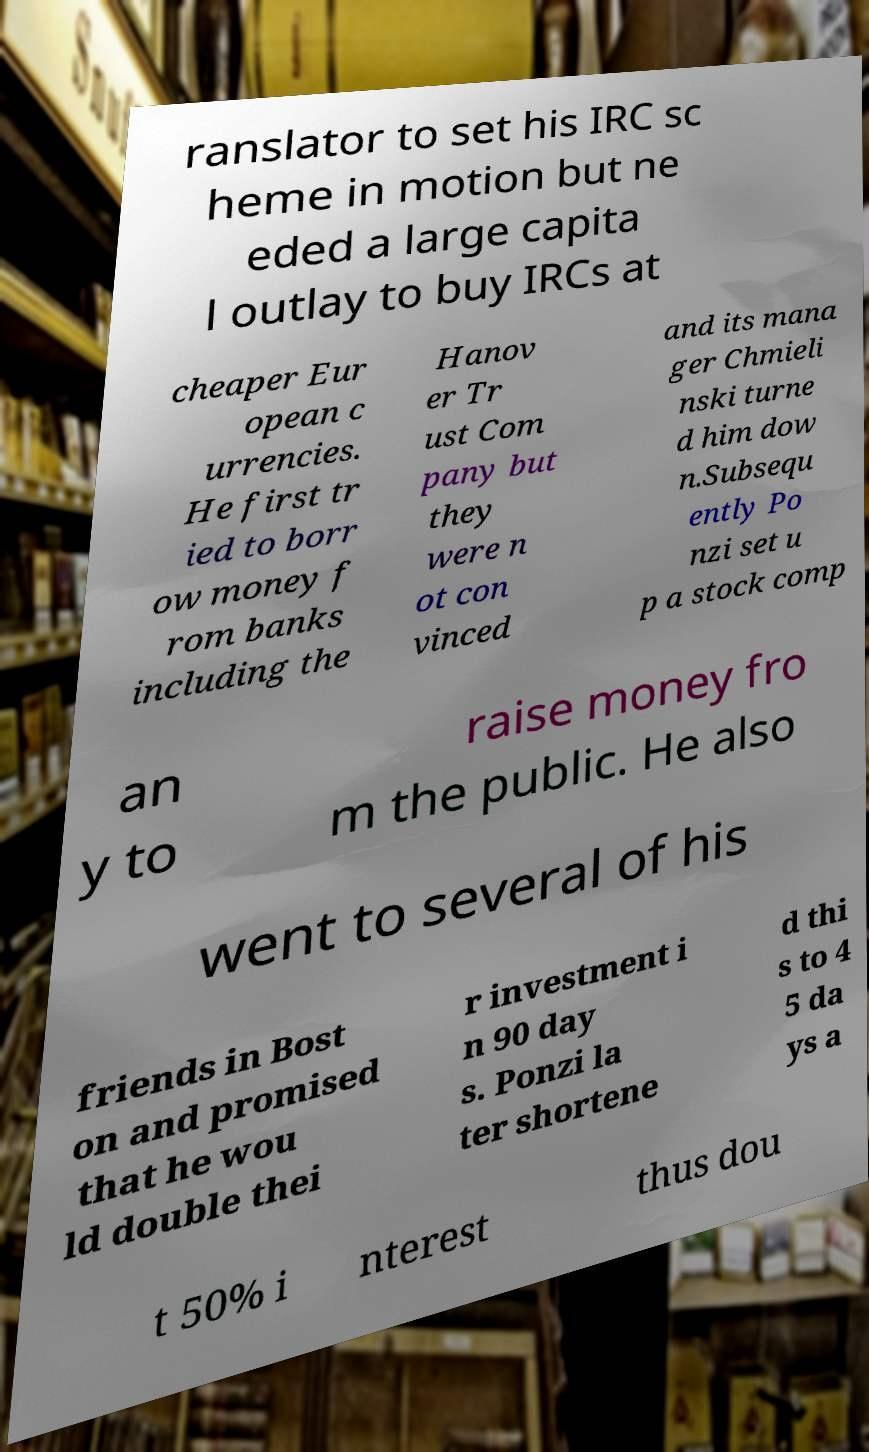Could you assist in decoding the text presented in this image and type it out clearly? ranslator to set his IRC sc heme in motion but ne eded a large capita l outlay to buy IRCs at cheaper Eur opean c urrencies. He first tr ied to borr ow money f rom banks including the Hanov er Tr ust Com pany but they were n ot con vinced and its mana ger Chmieli nski turne d him dow n.Subsequ ently Po nzi set u p a stock comp an y to raise money fro m the public. He also went to several of his friends in Bost on and promised that he wou ld double thei r investment i n 90 day s. Ponzi la ter shortene d thi s to 4 5 da ys a t 50% i nterest thus dou 